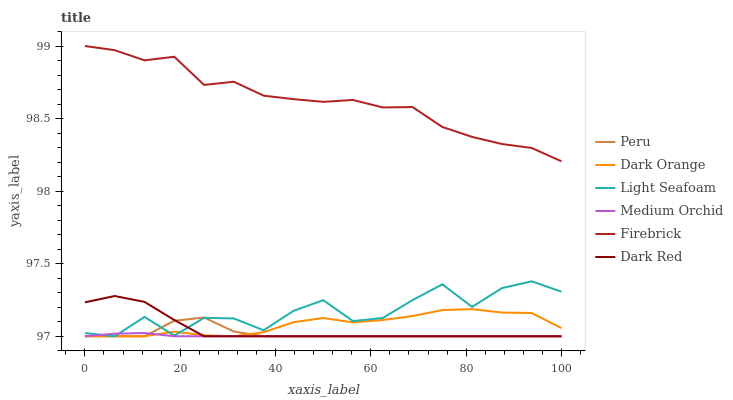Does Medium Orchid have the minimum area under the curve?
Answer yes or no. Yes. Does Firebrick have the maximum area under the curve?
Answer yes or no. Yes. Does Dark Red have the minimum area under the curve?
Answer yes or no. No. Does Dark Red have the maximum area under the curve?
Answer yes or no. No. Is Medium Orchid the smoothest?
Answer yes or no. Yes. Is Light Seafoam the roughest?
Answer yes or no. Yes. Is Dark Red the smoothest?
Answer yes or no. No. Is Dark Red the roughest?
Answer yes or no. No. Does Dark Orange have the lowest value?
Answer yes or no. Yes. Does Firebrick have the lowest value?
Answer yes or no. No. Does Firebrick have the highest value?
Answer yes or no. Yes. Does Dark Red have the highest value?
Answer yes or no. No. Is Dark Orange less than Firebrick?
Answer yes or no. Yes. Is Firebrick greater than Medium Orchid?
Answer yes or no. Yes. Does Light Seafoam intersect Dark Orange?
Answer yes or no. Yes. Is Light Seafoam less than Dark Orange?
Answer yes or no. No. Is Light Seafoam greater than Dark Orange?
Answer yes or no. No. Does Dark Orange intersect Firebrick?
Answer yes or no. No. 